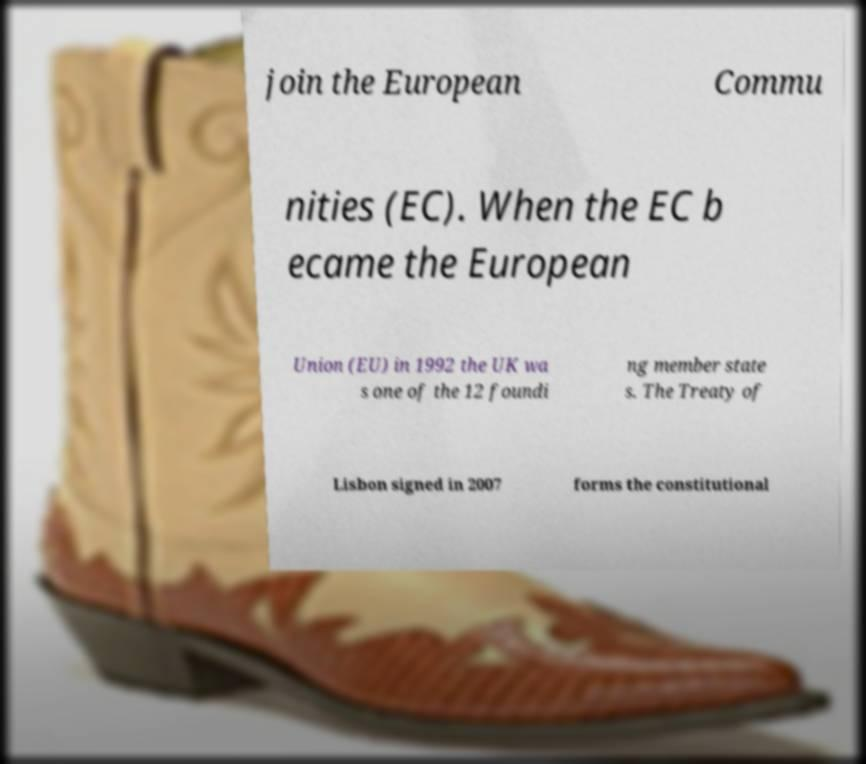For documentation purposes, I need the text within this image transcribed. Could you provide that? join the European Commu nities (EC). When the EC b ecame the European Union (EU) in 1992 the UK wa s one of the 12 foundi ng member state s. The Treaty of Lisbon signed in 2007 forms the constitutional 